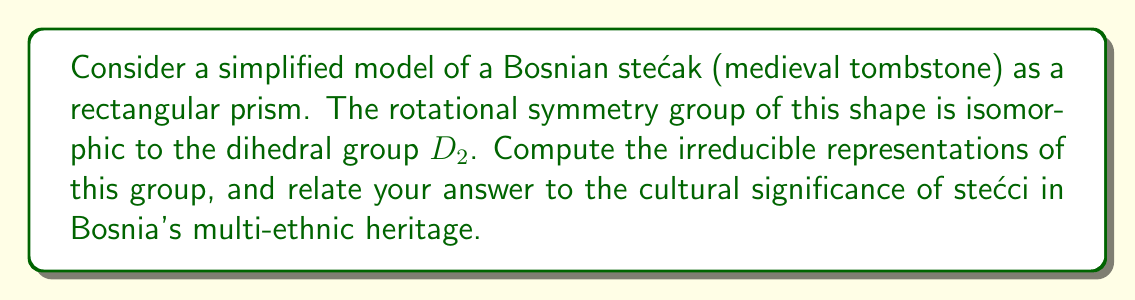Give your solution to this math problem. Let's approach this step-by-step:

1) The dihedral group $D_2$ is isomorphic to the Klein four-group $V_4$, which has four elements: $\{e, r_x, r_y, r_z\}$, where $e$ is the identity and $r_x, r_y, r_z$ are 180° rotations around the x, y, and z axes respectively.

2) To find the irreducible representations, we first need to find the conjugacy classes of $D_2$:
   - $\{e\}$
   - $\{r_x\}$
   - $\{r_y\}$
   - $\{r_z\}$

3) The number of irreducible representations is equal to the number of conjugacy classes, so we expect 4 irreducible representations.

4) For an abelian group like $D_2$, all irreducible representations are 1-dimensional.

5) We can construct the character table for $D_2$:

   $$\begin{array}{c|cccc}
      & e & r_x & r_y & r_z \\
   \hline
   \chi_1 & 1 & 1 & 1 & 1 \\
   \chi_2 & 1 & 1 & -1 & -1 \\
   \chi_3 & 1 & -1 & 1 & -1 \\
   \chi_4 & 1 & -1 & -1 & 1
   \end{array}$$

6) Each row in this table corresponds to an irreducible representation.

7) Relating to Bosnia's cultural heritage: The four irreducible representations can be seen as symbolizing the four major ethnic groups that have historically inhabited Bosnia (Bosniaks, Serbs, Croats, and Jews), each contributing to the rich tapestry of Bosnian culture, just as each representation contributes to the complete description of the symmetry group.
Answer: The irreducible representations of $D_2$ are the four 1-dimensional representations given by the character table: $\chi_1 = (1,1,1,1)$, $\chi_2 = (1,1,-1,-1)$, $\chi_3 = (1,-1,1,-1)$, $\chi_4 = (1,-1,-1,1)$. 